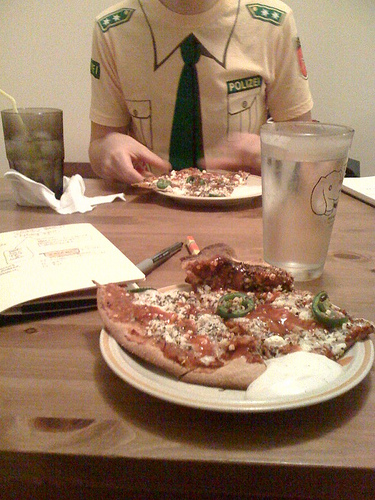Describe the meal that is seen on the table. On the table, there's a plate with a few slices of pizza, one of which appears to have toppings like jalapeños and possibly pepperoni. Next to the plate is a glass of water and some other objects that are not clearly discernible. 